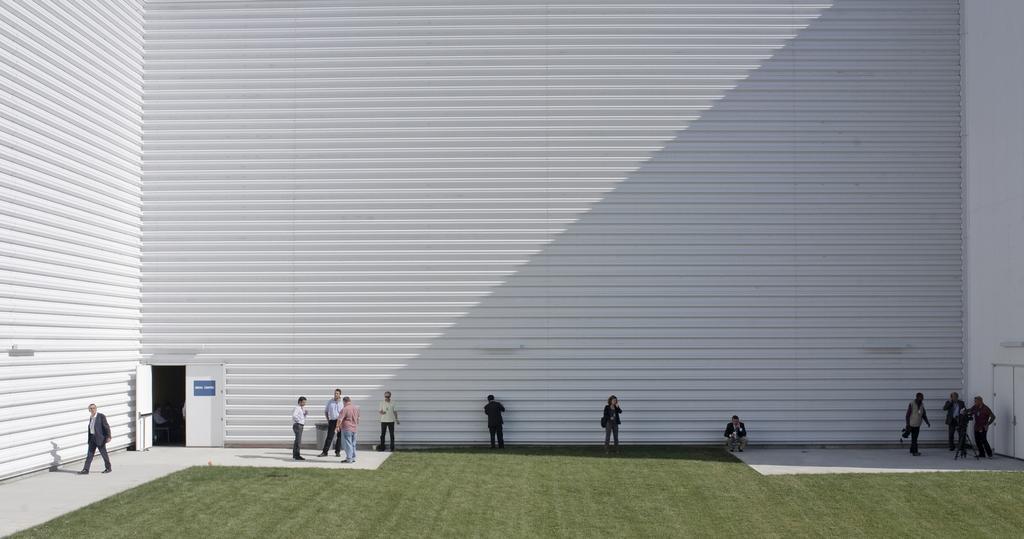How would you summarize this image in a sentence or two? At the bottom of the image we can see persons, grass, door. In the background there is a wall. 